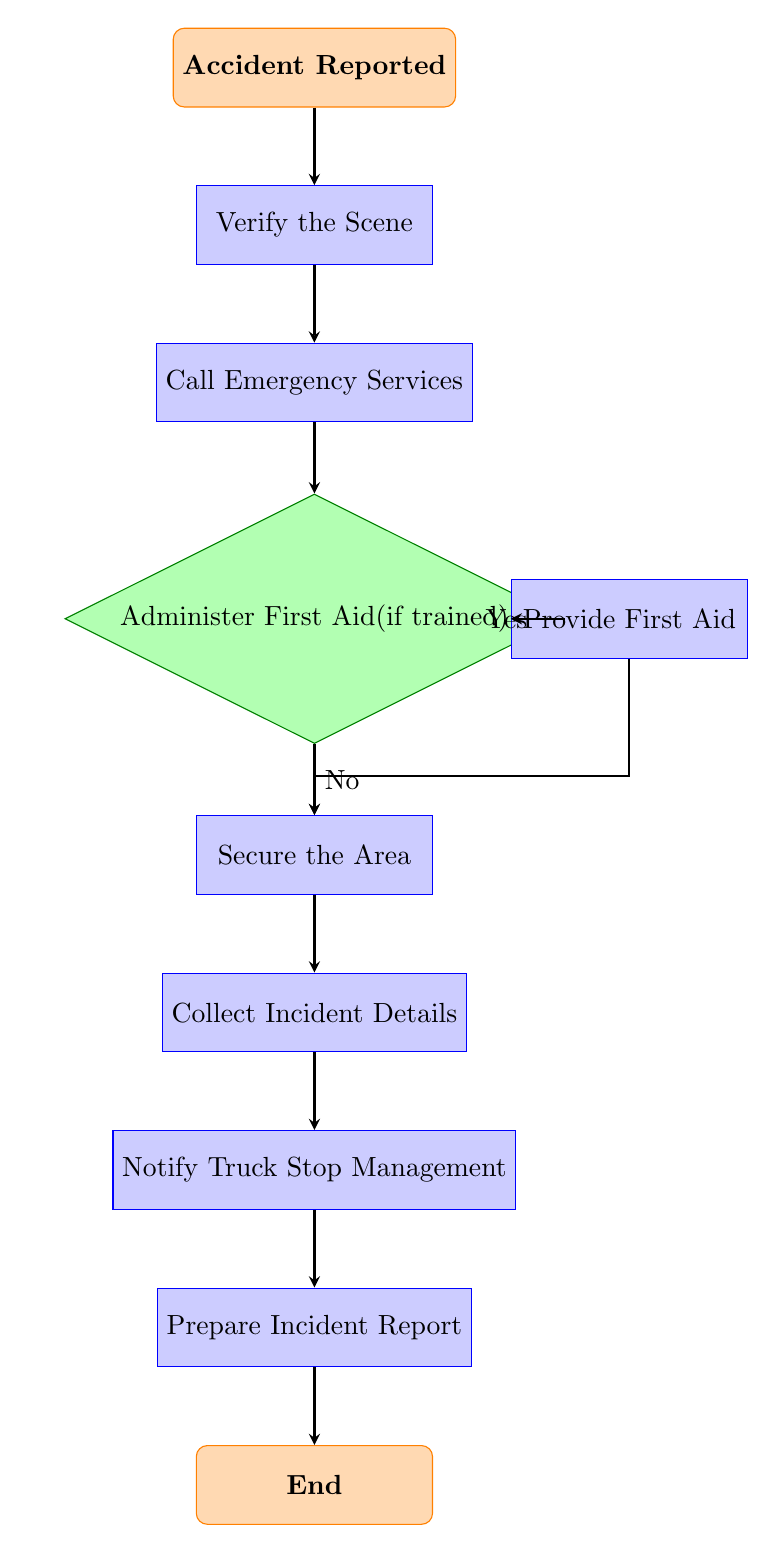What is the first step after an accident is reported? The first step is to "Verify the Scene" which is the immediate action taken following the incident report.
Answer: Verify the Scene How many decision nodes are present in the flow chart? There is only one decision node, which is "Administer First Aid (if trained)."
Answer: 1 What action follows the "Call Emergency Services"? The action that follows is "Administer First Aid (if trained)," as it directly comes after the emergency services are contacted.
Answer: Administer First Aid (if trained) What are the two outcomes of the decision node? The two outcomes are "Provide First Aid" if the answer is yes, and "Secure the Area" if the answer is no.
Answer: Provide First Aid, Secure the Area What is the final step before the flow chart ends? The final step before the end of the procedure is to "Prepare Incident Report." This is the last process that occurs in the flow of actions.
Answer: Prepare Incident Report 